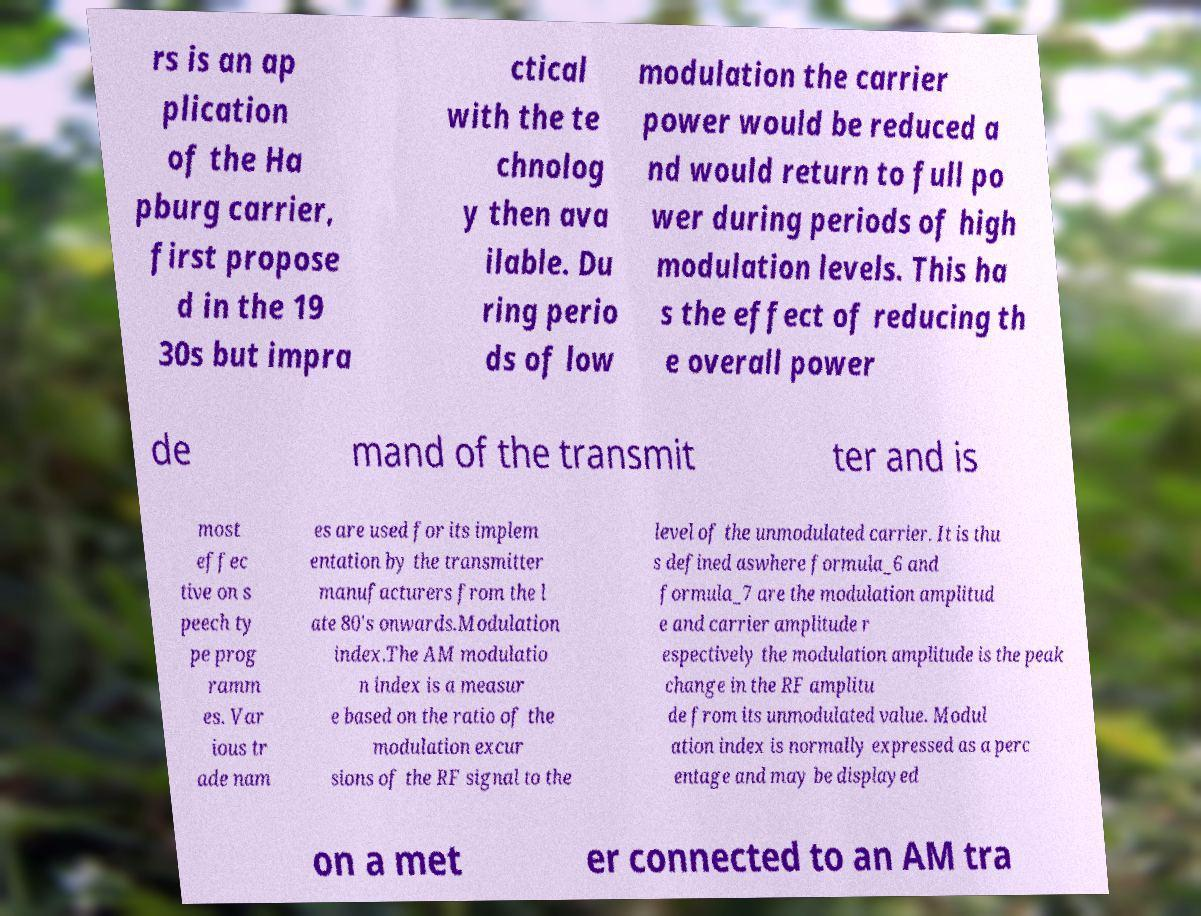What messages or text are displayed in this image? I need them in a readable, typed format. rs is an ap plication of the Ha pburg carrier, first propose d in the 19 30s but impra ctical with the te chnolog y then ava ilable. Du ring perio ds of low modulation the carrier power would be reduced a nd would return to full po wer during periods of high modulation levels. This ha s the effect of reducing th e overall power de mand of the transmit ter and is most effec tive on s peech ty pe prog ramm es. Var ious tr ade nam es are used for its implem entation by the transmitter manufacturers from the l ate 80's onwards.Modulation index.The AM modulatio n index is a measur e based on the ratio of the modulation excur sions of the RF signal to the level of the unmodulated carrier. It is thu s defined aswhere formula_6 and formula_7 are the modulation amplitud e and carrier amplitude r espectively the modulation amplitude is the peak change in the RF amplitu de from its unmodulated value. Modul ation index is normally expressed as a perc entage and may be displayed on a met er connected to an AM tra 